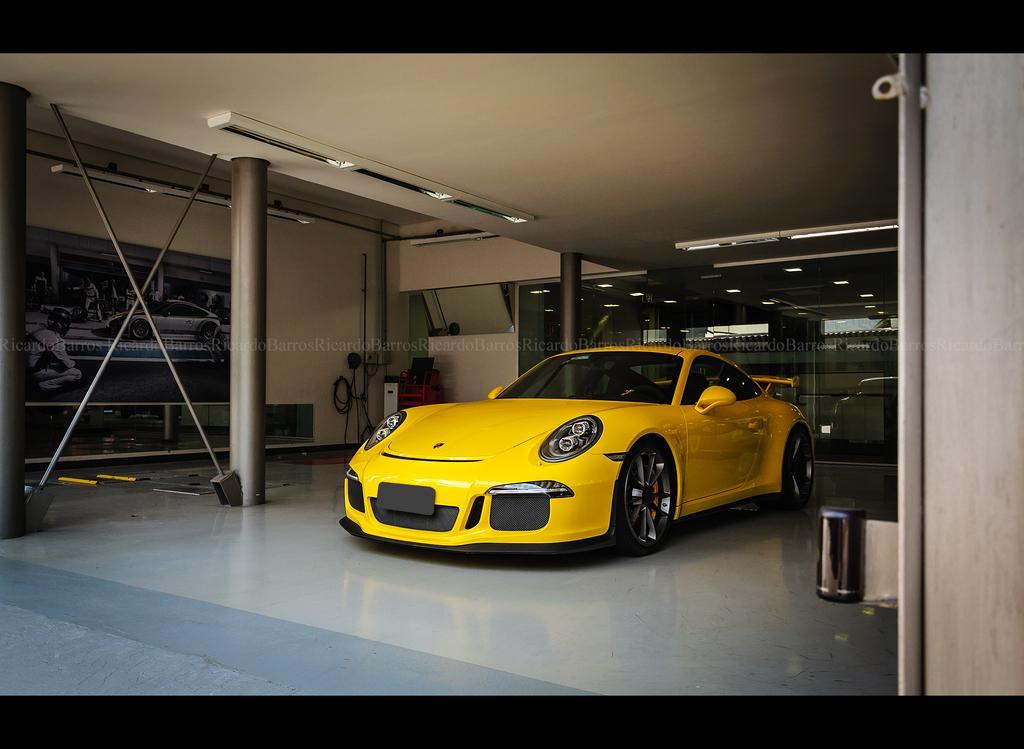Could you give a brief overview of what you see in this image? In the middle there is a beautiful yellow color car, behind this there is a glass wall. 